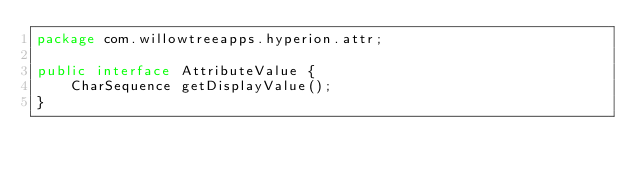Convert code to text. <code><loc_0><loc_0><loc_500><loc_500><_Java_>package com.willowtreeapps.hyperion.attr;

public interface AttributeValue {
    CharSequence getDisplayValue();
}</code> 